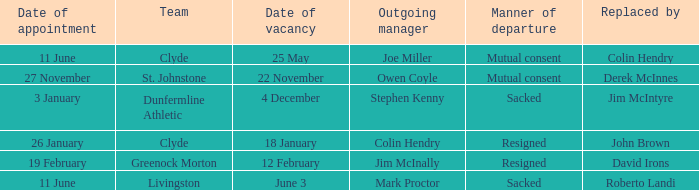Tell me the outgoing manager for 22 november date of vacancy Owen Coyle. 